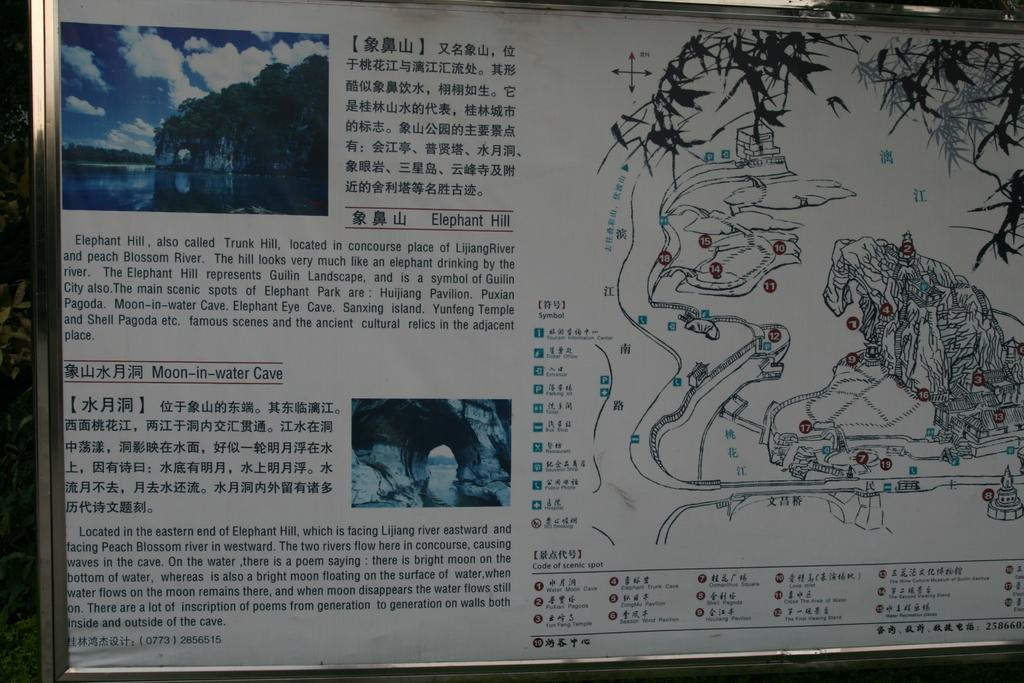What is the main object in the picture? There is a board in the picture. What is depicted on the right side of the board? There is a map on the right side of the board. What can be seen on the left side of the board? There are two pictures on the left side of the board. Are there any words or letters on or near the board? Yes, there is text written on or near the board. What type of vegetable is being used as a whistle in the image? There is no vegetable or whistle present in the image. 